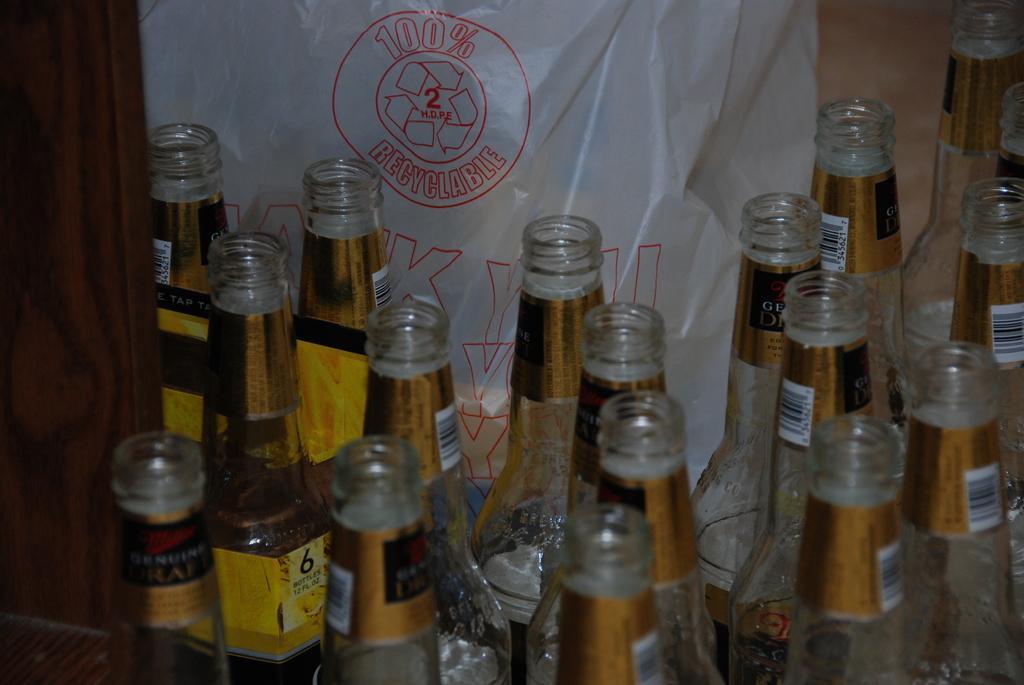How would you summarize this image in a sentence or two? There are some glass bottles in the image. In the left side we can see one of the bottle is filled with some content, background there is a white color polythene carry bag in which it is written as 100 percent recyclable. 